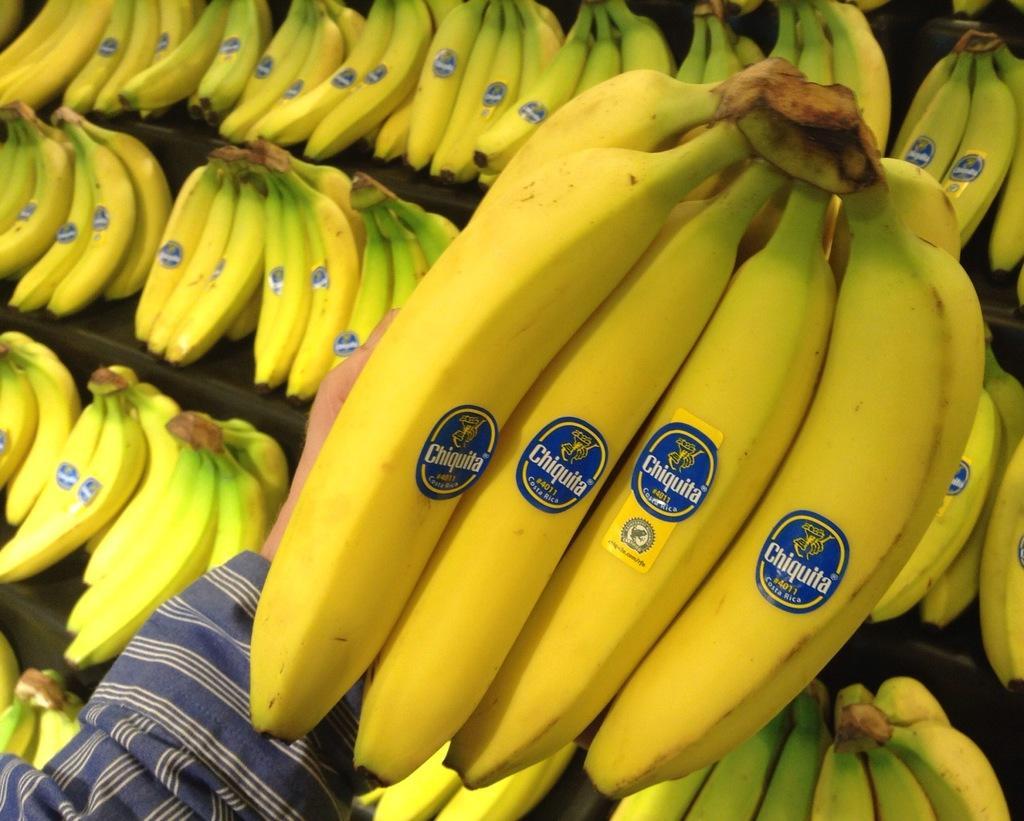In one or two sentences, can you explain what this image depicts? Here we can see bananas,on these bananas we can see stickers and we can see bananas hold with hand. 